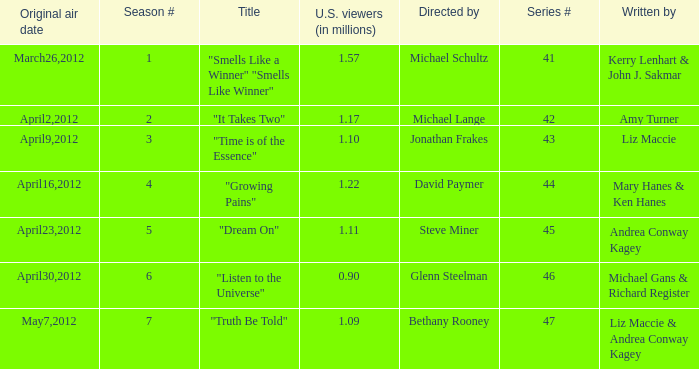What is the name of the episodes which had 1.22 million U.S. viewers? "Growing Pains". 